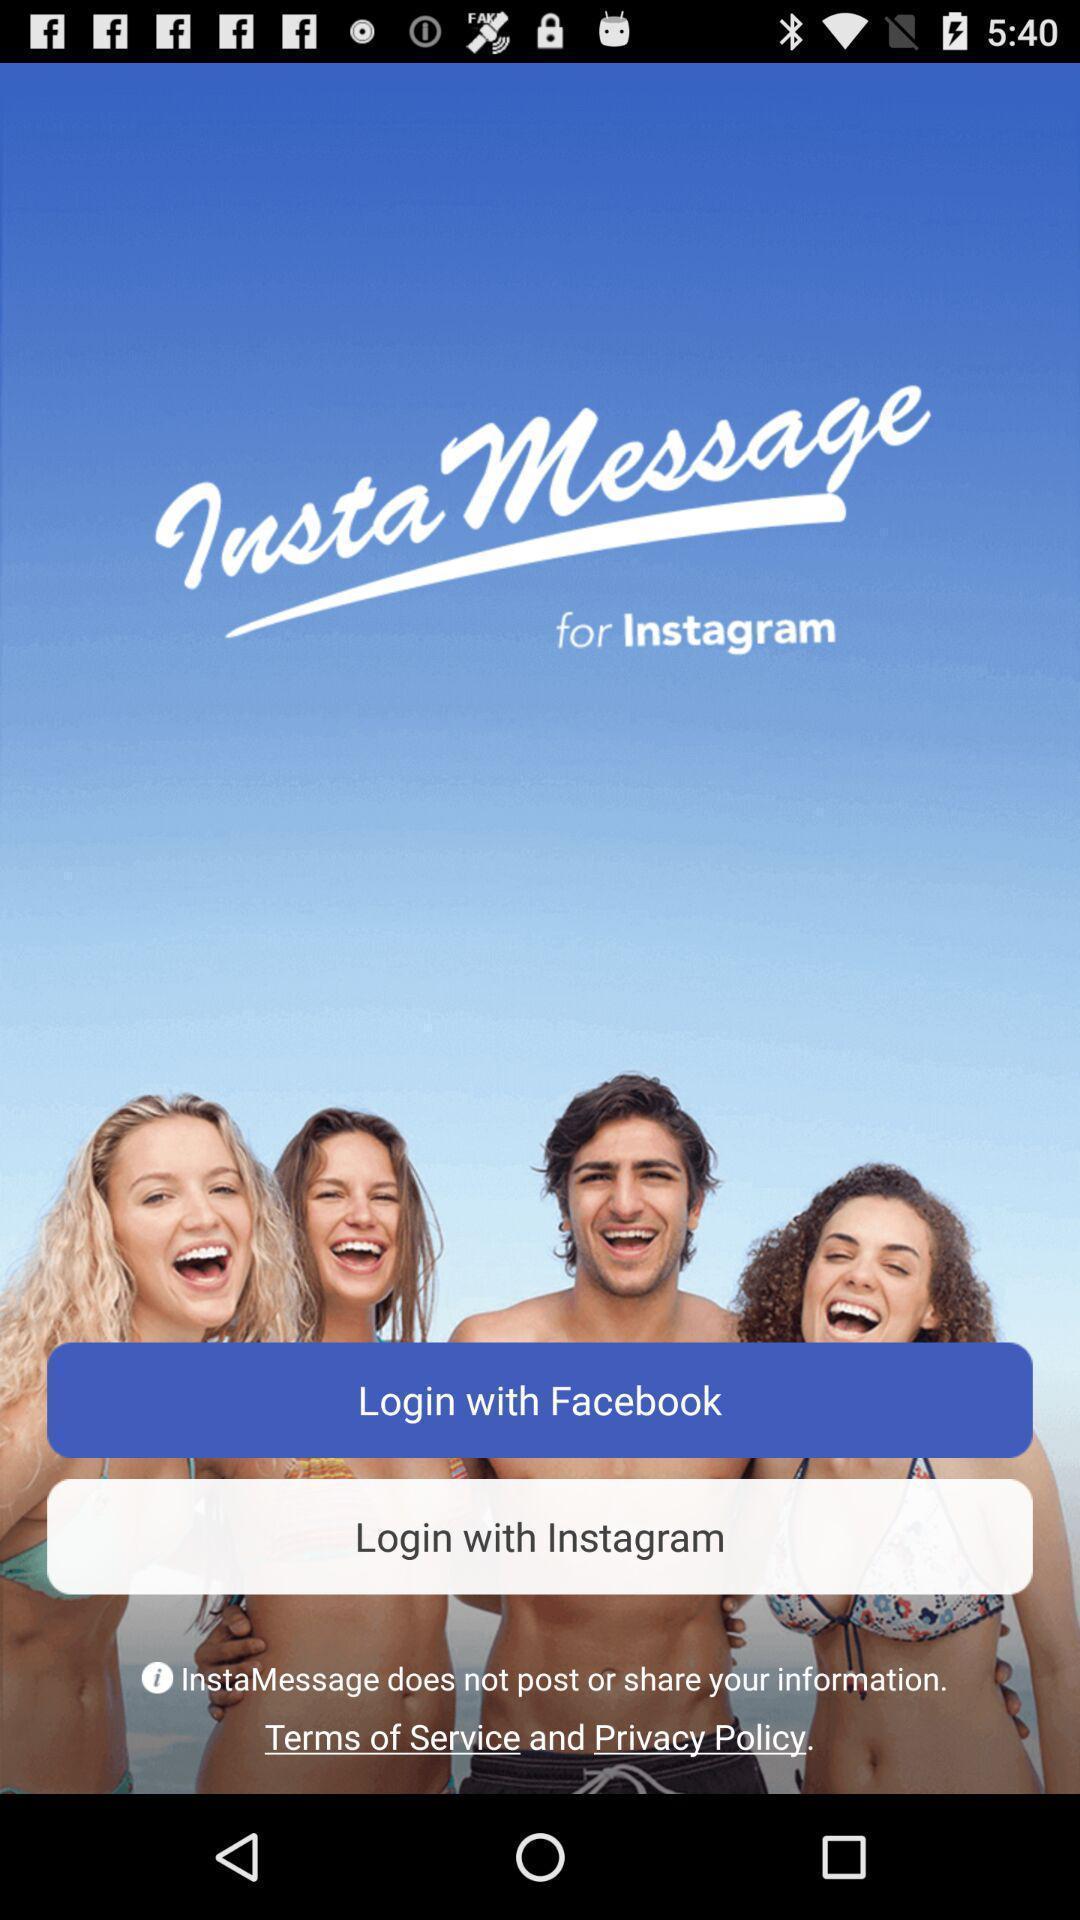Describe this image in words. Welcome page of a social networking app. 